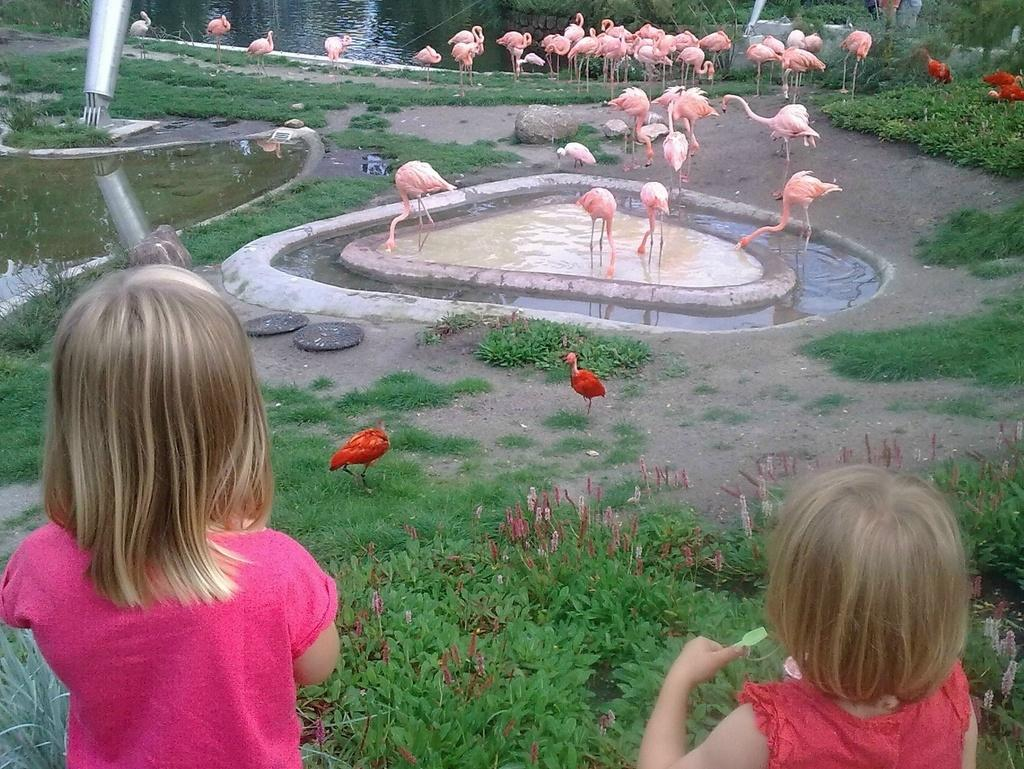How many children are present in the image? There are two children standing in the image. What type of vegetation can be seen in the image? There are plants, grass, and trees visible in the image. What animals are present in the image? There is a group of birds in the image. What natural element is visible in the image? Water is visible in the image. What other objects can be seen in the image? There are stones and a pole in the image. Can you tell me what type of soup the children are holding in the image? There is no soup present in the image; the children are not holding anything. 